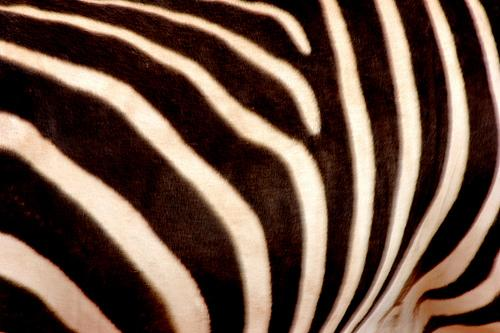What could be a possible title for this image for an advertisement? "Experience the Wild - Witness the Unique Patterns of the Majestic Zebra" Mention one possible reason why the zebra in the image may have evolved to have black and white striped fur. One possible reason is that the zebra's striped fur may function as a form of camouflage, enabling it to blend in with its surroundings and confuse predators. Identify the primary object within the image. The primary object in this image is a zebra with black and white stripes. Using descriptive language, provide a brief overview of the image. This captivating image captures the intricacies of a zebra's mesmerizing black and white striped pattern, giving us a glimpse into the beauty of the animal kingdom. In a referential expression grounding task, choose one specific part of the image and describe it in detail. The convergence of several white stripes in the center of the image forms a striking focal point, surrounded by contrasting patches of black fur. In the context of a multiple choice VQA task, what question could you ask about this image? Which animal is present in this image? a) Zebra b) Elephant c) Giraffe d) Tiger Tell me an interesting fact about the depicted subject in the image. Zebras' unique black and white striped pattern may serve to confuse predators by creating a distracting optical illusion. Explain the main focus of this image for a visual entailment task. The main focus of this image is to analyze the pattern of black and white stripes on a zebra's body. Which animal is featured in the image and mention two colorful characteristics of it. The image features a zebra with black stripes and white stripes. Create an advertisement slogan for a product inspired by this image. "Unleash Your Wild Side: Our Zebra-Striped Apparel Lets You Stand Out and Make a Statement" 